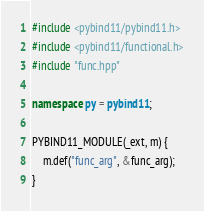<code> <loc_0><loc_0><loc_500><loc_500><_C++_>#include <pybind11/pybind11.h>
#include <pybind11/functional.h>
#include "func.hpp"

namespace py = pybind11;

PYBIND11_MODULE(_ext, m) {
    m.def("func_arg", &func_arg);
}
</code> 